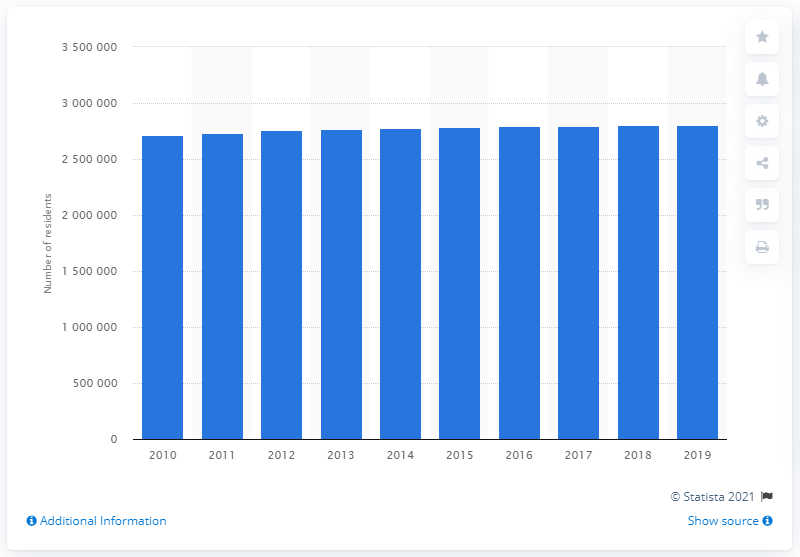Specify some key components in this picture. In the year 2019, the Baltimore-Columbia-Towson metropolitan area had a population of approximately 278,0055 people. 